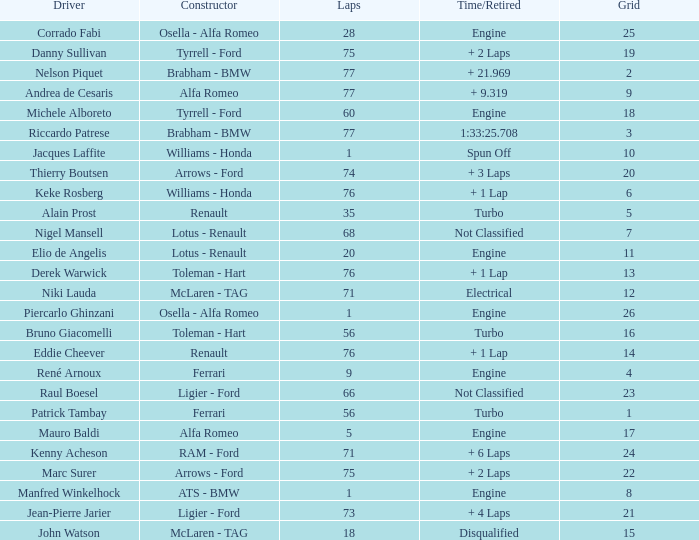Who drive the car that went under 60 laps and spun off? Jacques Laffite. 